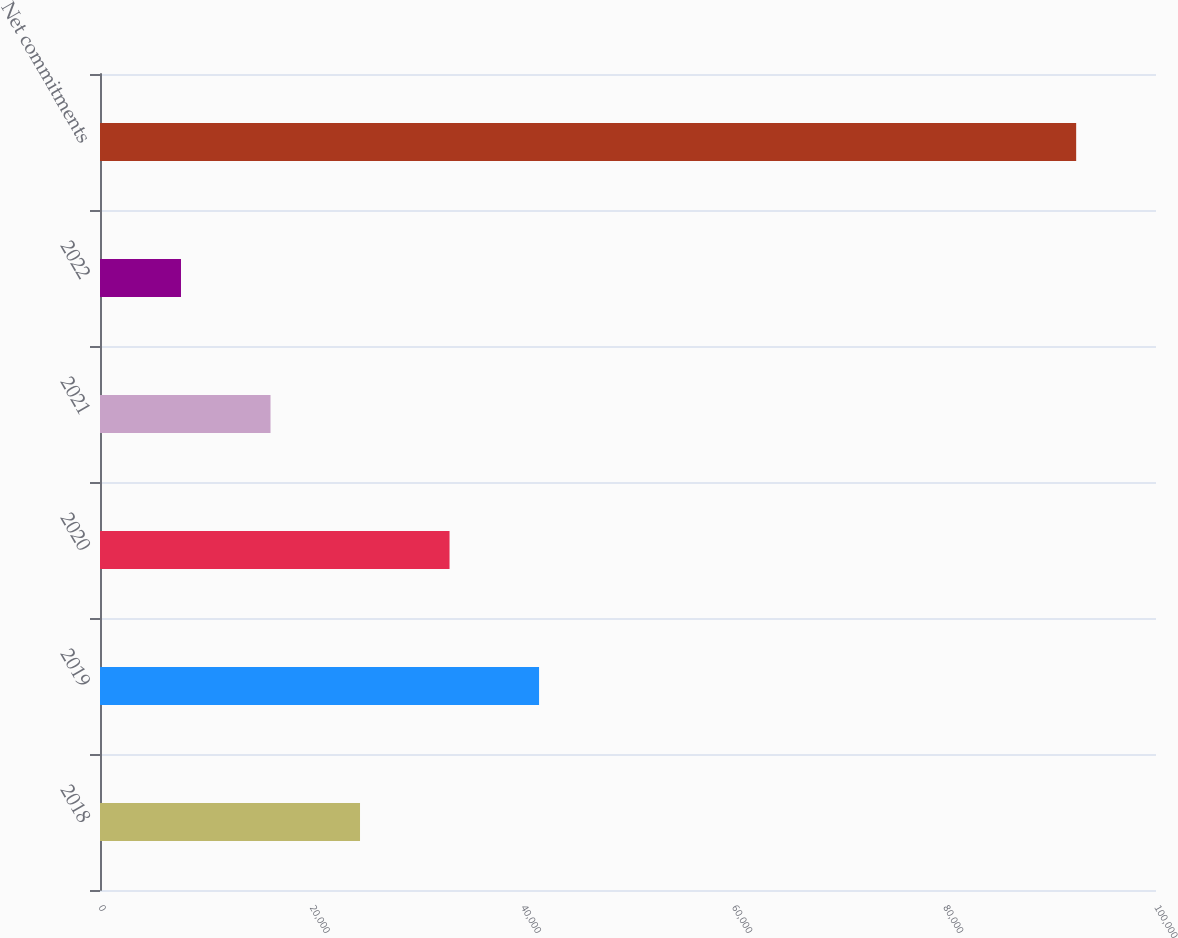Convert chart. <chart><loc_0><loc_0><loc_500><loc_500><bar_chart><fcel>2018<fcel>2019<fcel>2020<fcel>2021<fcel>2022<fcel>Net commitments<nl><fcel>24623.2<fcel>41577.4<fcel>33100.3<fcel>16146.1<fcel>7669<fcel>92440<nl></chart> 